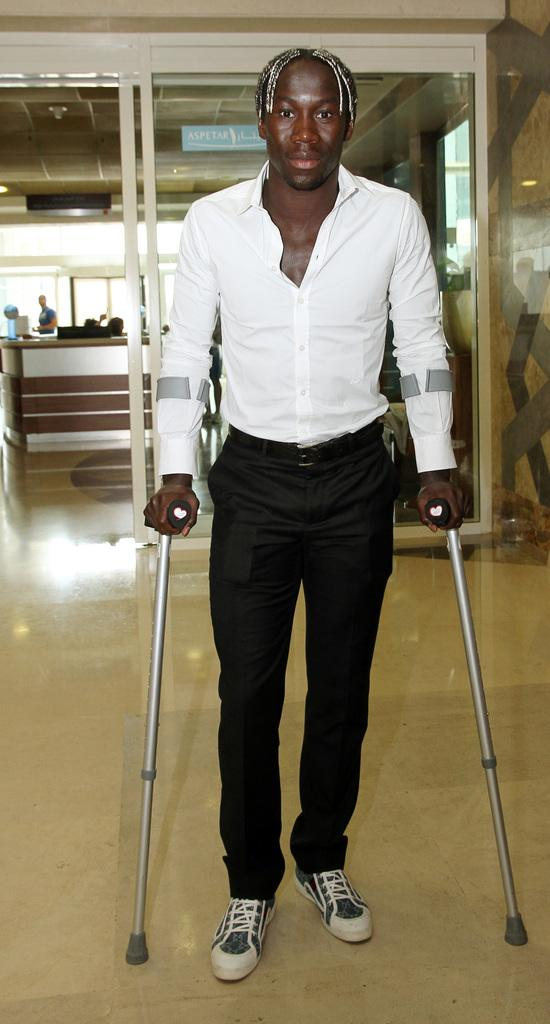Who is the main subject in the image? There is a man in the center of the image. What is the man doing in the image? The man is standing with walking sticks. Where is the man located in the image? The man is on the floor. What can be seen in the background of the image? There is a door, a table, a person, and a wall in the background of the image. What type of wood is the cake made of in the image? There is no cake present in the image, and therefore no wood or any other material used to make it. 